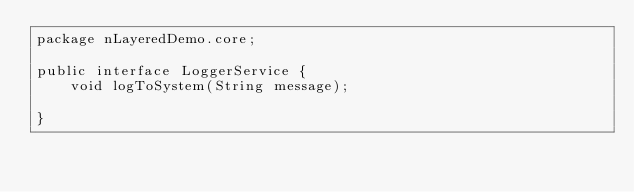<code> <loc_0><loc_0><loc_500><loc_500><_Java_>package nLayeredDemo.core;

public interface LoggerService {
	void logToSystem(String message);
	
}
</code> 